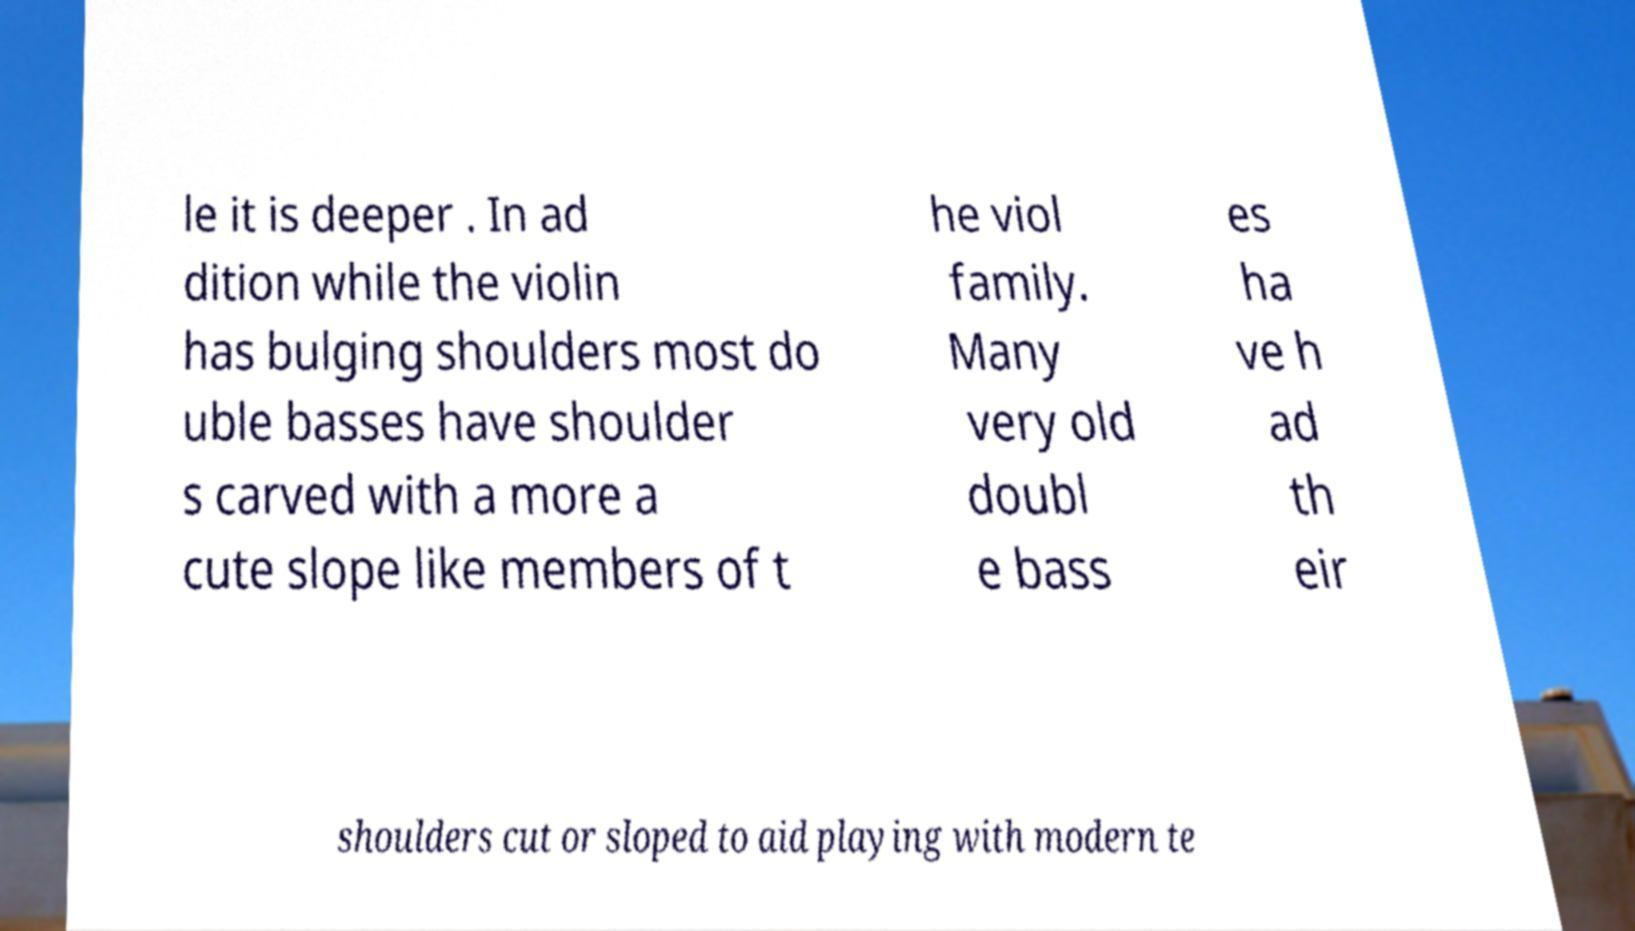Can you read and provide the text displayed in the image?This photo seems to have some interesting text. Can you extract and type it out for me? le it is deeper . In ad dition while the violin has bulging shoulders most do uble basses have shoulder s carved with a more a cute slope like members of t he viol family. Many very old doubl e bass es ha ve h ad th eir shoulders cut or sloped to aid playing with modern te 